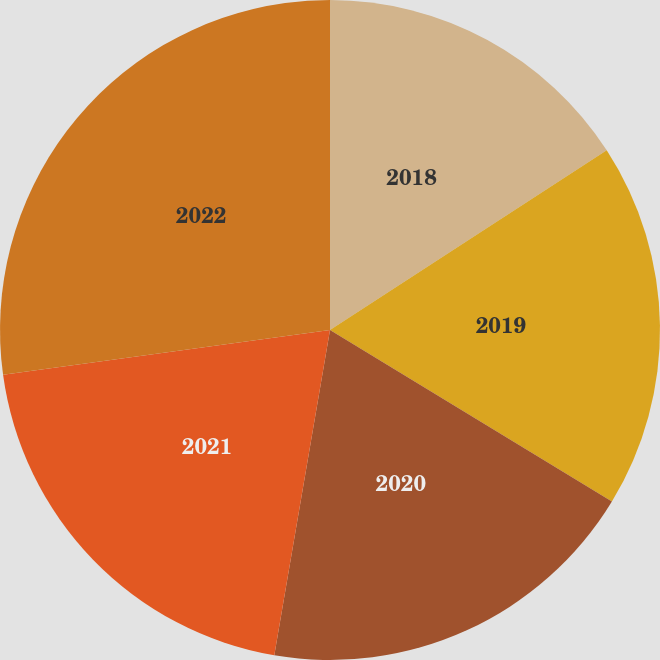Convert chart. <chart><loc_0><loc_0><loc_500><loc_500><pie_chart><fcel>2018<fcel>2019<fcel>2020<fcel>2021<fcel>2022<nl><fcel>15.83%<fcel>17.87%<fcel>19.0%<fcel>20.13%<fcel>27.17%<nl></chart> 